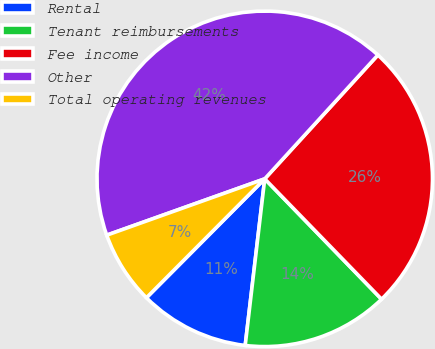Convert chart to OTSL. <chart><loc_0><loc_0><loc_500><loc_500><pie_chart><fcel>Rental<fcel>Tenant reimbursements<fcel>Fee income<fcel>Other<fcel>Total operating revenues<nl><fcel>10.6%<fcel>14.12%<fcel>25.95%<fcel>42.23%<fcel>7.09%<nl></chart> 